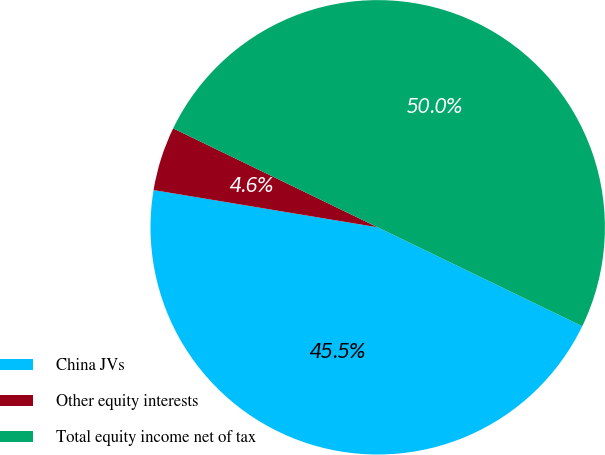Convert chart. <chart><loc_0><loc_0><loc_500><loc_500><pie_chart><fcel>China JVs<fcel>Other equity interests<fcel>Total equity income net of tax<nl><fcel>45.45%<fcel>4.55%<fcel>50.0%<nl></chart> 